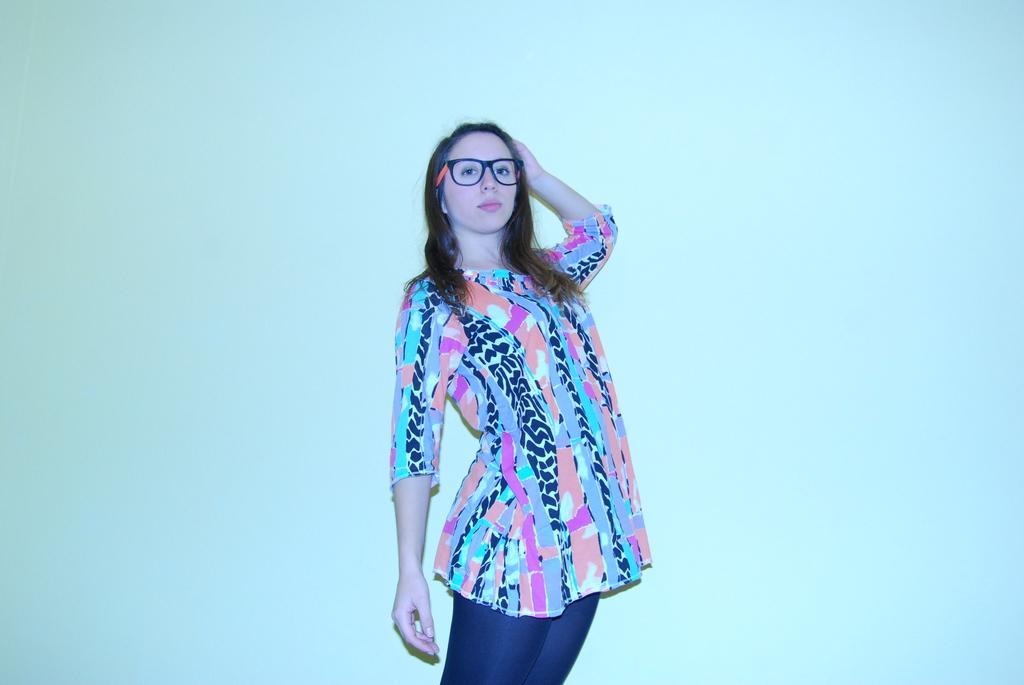How would you summarize this image in a sentence or two? In this image in front there is a person. Behind her there is a wall. 